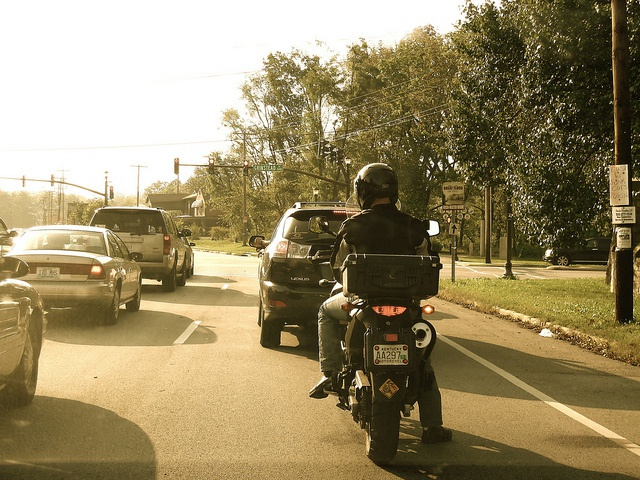Describe the objects in this image and their specific colors. I can see motorcycle in white, black, olive, maroon, and tan tones, people in white, black, olive, and tan tones, car in white, olive, tan, and ivory tones, car in white, black, olive, and ivory tones, and car in white, olive, and tan tones in this image. 